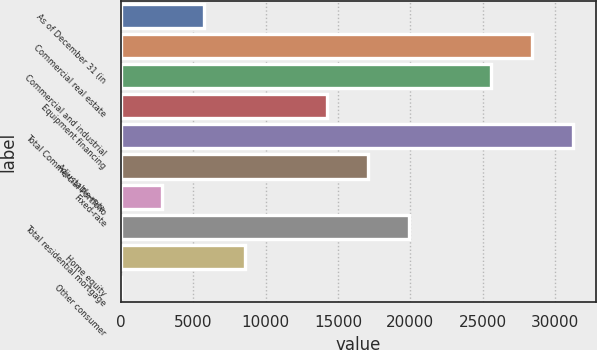Convert chart. <chart><loc_0><loc_0><loc_500><loc_500><bar_chart><fcel>As of December 31 (in<fcel>Commercial real estate<fcel>Commercial and industrial<fcel>Equipment financing<fcel>Total Commercial Portfolio<fcel>Adjustable-rate<fcel>Fixed-rate<fcel>Total residential mortgage<fcel>Home equity<fcel>Other consumer<nl><fcel>5721.7<fcel>28410.9<fcel>25574.8<fcel>14230.1<fcel>31247<fcel>17066.3<fcel>2885.55<fcel>19902.5<fcel>8557.85<fcel>49.4<nl></chart> 